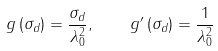Convert formula to latex. <formula><loc_0><loc_0><loc_500><loc_500>g \left ( \sigma _ { d } \right ) = \frac { \sigma _ { d } } { \lambda _ { 0 } ^ { 2 } } , \quad g ^ { \prime } \left ( \sigma _ { d } \right ) = \frac { 1 } { \lambda _ { 0 } ^ { 2 } }</formula> 